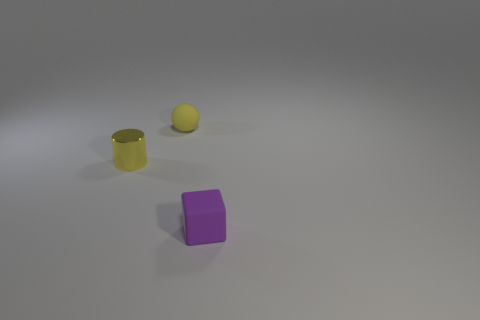What materials do these objects appear to be made from? The cube looks to have a rubbery texture suggesting it's made of rubber, and the sphere has a matte finish, which could imply it's made of a plastic or coated material. The cylindrical object has a reflective surface that hints at a metallic construction, potentially aluminum or steel. 